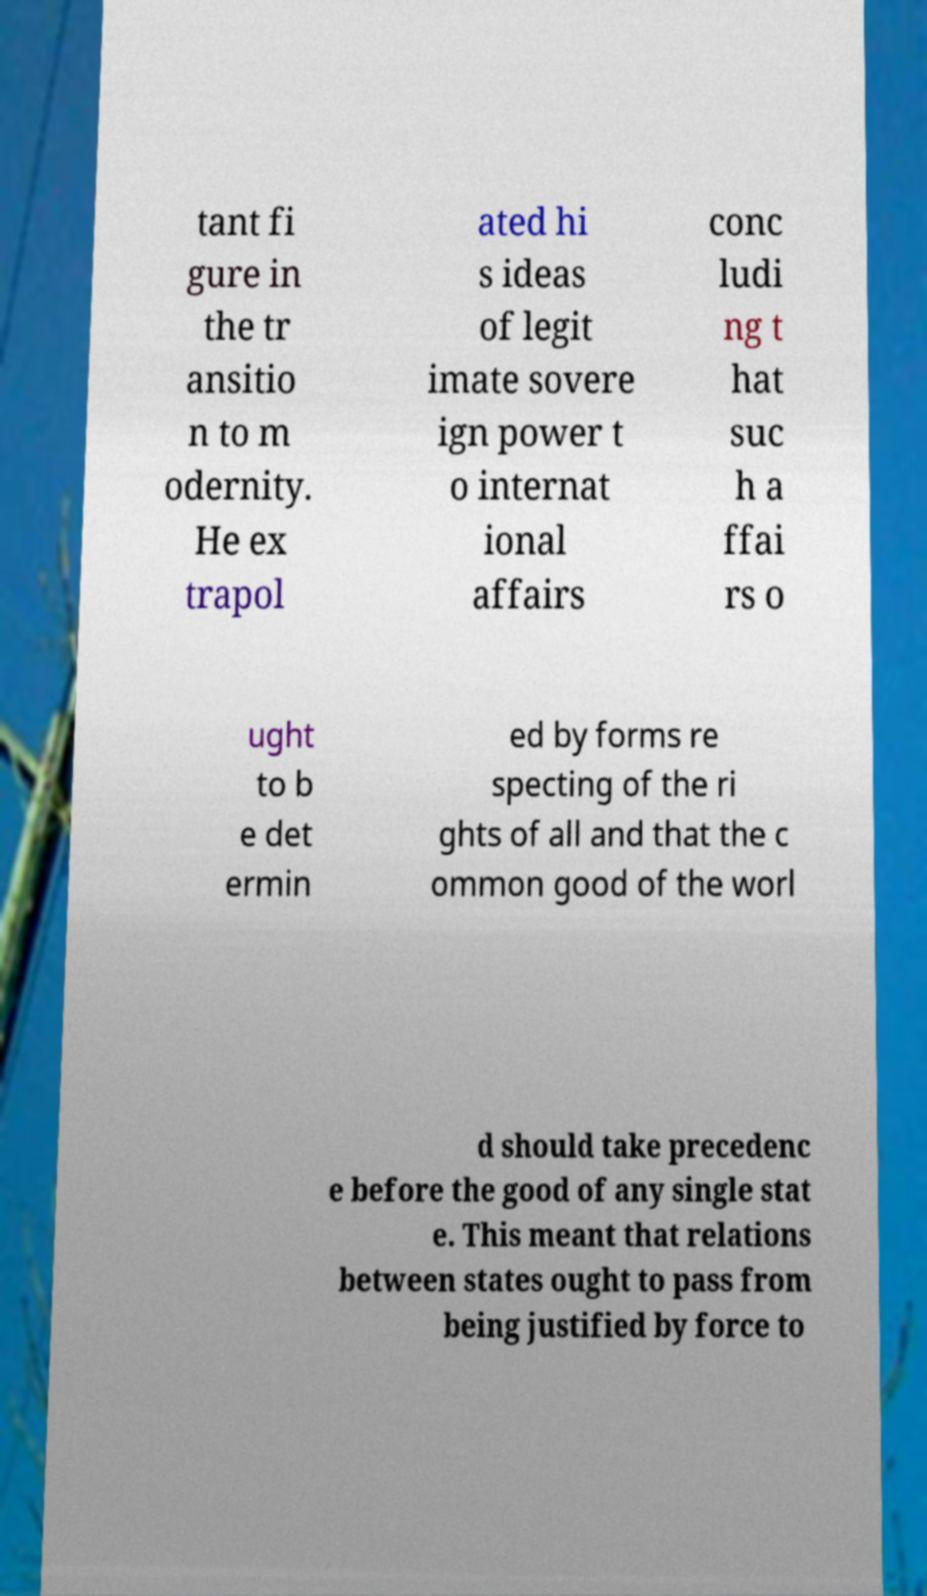I need the written content from this picture converted into text. Can you do that? tant fi gure in the tr ansitio n to m odernity. He ex trapol ated hi s ideas of legit imate sovere ign power t o internat ional affairs conc ludi ng t hat suc h a ffai rs o ught to b e det ermin ed by forms re specting of the ri ghts of all and that the c ommon good of the worl d should take precedenc e before the good of any single stat e. This meant that relations between states ought to pass from being justified by force to 